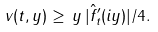<formula> <loc_0><loc_0><loc_500><loc_500>v ( t , y ) \geq \, y \, | \hat { f } _ { t } ^ { \prime } ( i y ) | / 4 .</formula> 